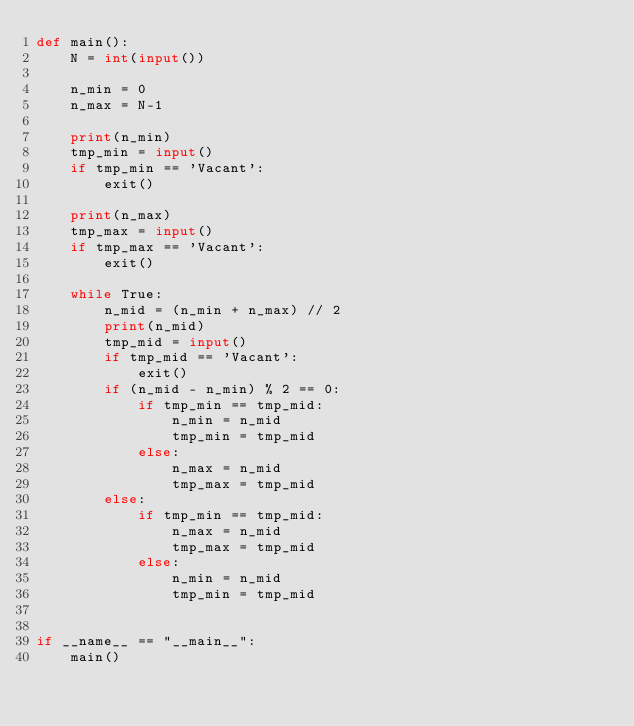Convert code to text. <code><loc_0><loc_0><loc_500><loc_500><_Python_>def main():
    N = int(input())

    n_min = 0
    n_max = N-1

    print(n_min)
    tmp_min = input()
    if tmp_min == 'Vacant':
        exit()

    print(n_max)
    tmp_max = input()
    if tmp_max == 'Vacant':
        exit()

    while True:
        n_mid = (n_min + n_max) // 2
        print(n_mid)
        tmp_mid = input()
        if tmp_mid == 'Vacant':
            exit()
        if (n_mid - n_min) % 2 == 0:
            if tmp_min == tmp_mid:
                n_min = n_mid
                tmp_min = tmp_mid
            else:
                n_max = n_mid
                tmp_max = tmp_mid
        else:
            if tmp_min == tmp_mid:
                n_max = n_mid
                tmp_max = tmp_mid
            else:
                n_min = n_mid
                tmp_min = tmp_mid


if __name__ == "__main__":
    main()
</code> 